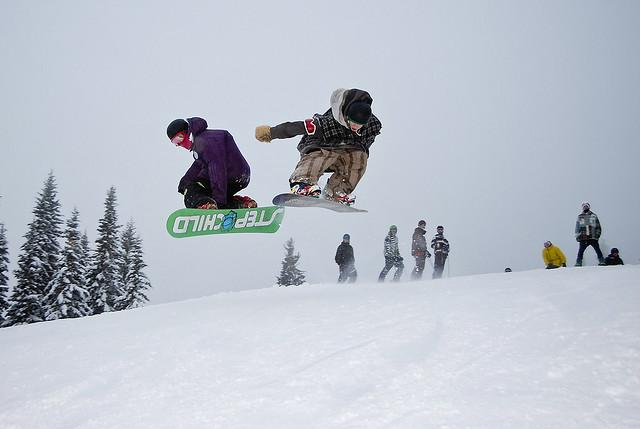Which famous person fits the description on the bottom of the board? Please explain your reasoning. zoe kravitz. The person is zoe. 